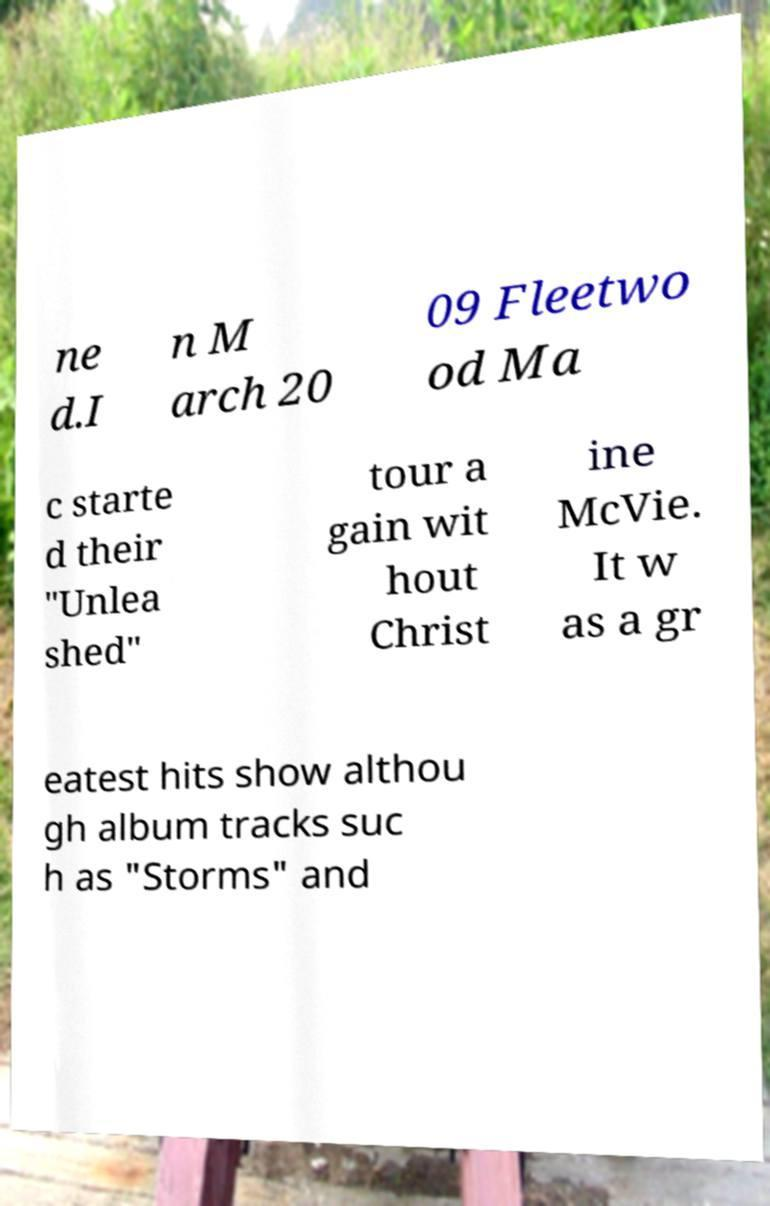Can you read and provide the text displayed in the image?This photo seems to have some interesting text. Can you extract and type it out for me? ne d.I n M arch 20 09 Fleetwo od Ma c starte d their "Unlea shed" tour a gain wit hout Christ ine McVie. It w as a gr eatest hits show althou gh album tracks suc h as "Storms" and 